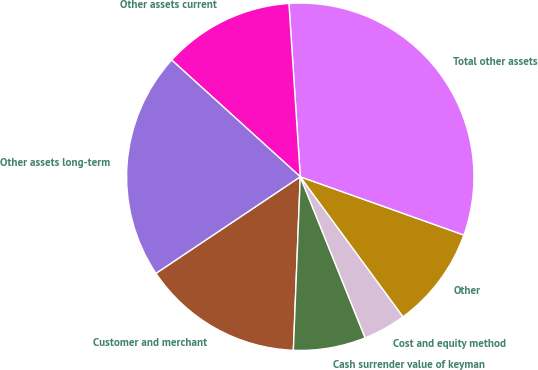Convert chart. <chart><loc_0><loc_0><loc_500><loc_500><pie_chart><fcel>Customer and merchant<fcel>Cash surrender value of keyman<fcel>Cost and equity method<fcel>Other<fcel>Total other assets<fcel>Other assets current<fcel>Other assets long-term<nl><fcel>14.98%<fcel>6.73%<fcel>3.98%<fcel>9.48%<fcel>31.49%<fcel>12.23%<fcel>21.12%<nl></chart> 